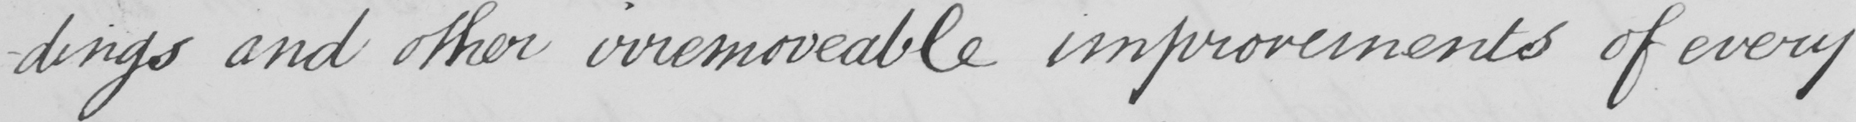What text is written in this handwritten line? -dings and other irremoveable improvements of every 